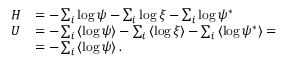<formula> <loc_0><loc_0><loc_500><loc_500>\begin{array} { r l } { H } & { = - \sum _ { i } \log \psi - \sum _ { i } \log \xi - \sum _ { i } \log \psi ^ { * } } \\ { U } & { = - \sum _ { i } \left \langle \log \psi \right \rangle - \sum _ { i } \left \langle \log \xi \right \rangle - \sum _ { i } \left \langle \log \psi ^ { * } \right \rangle = } \\ & { = - \sum _ { i } \left \langle \log \psi \right \rangle . } \end{array}</formula> 